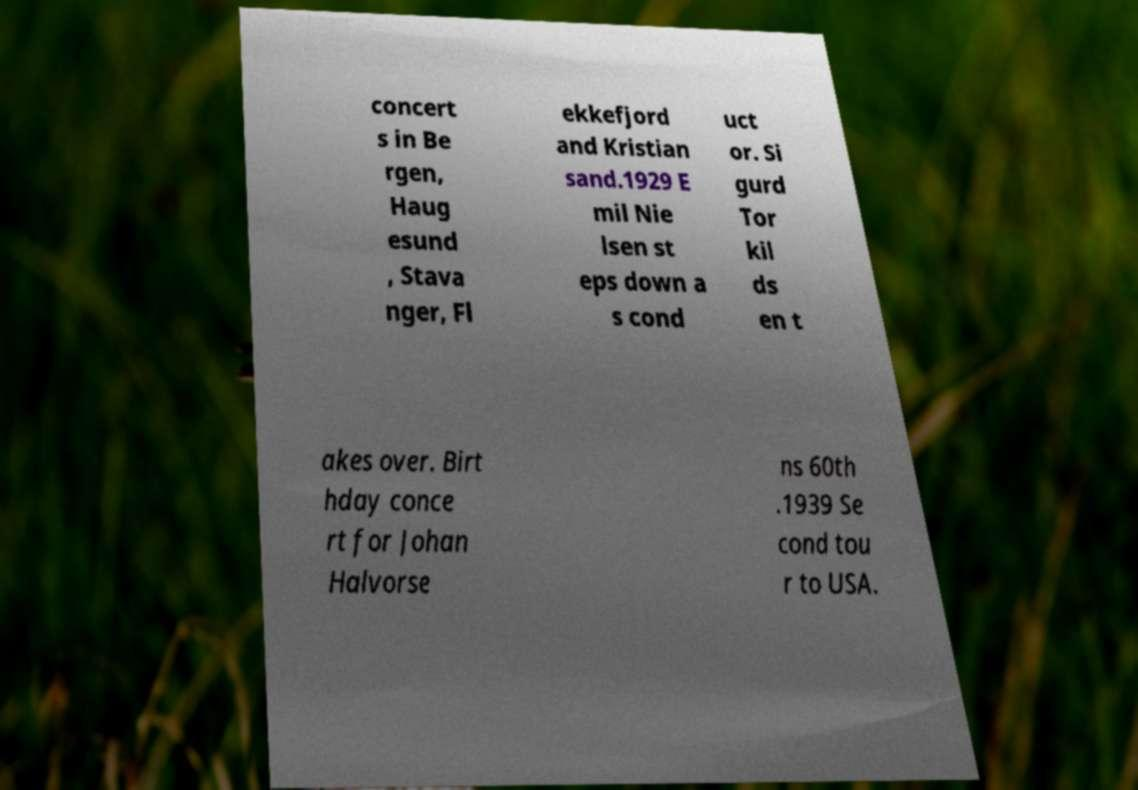Can you read and provide the text displayed in the image?This photo seems to have some interesting text. Can you extract and type it out for me? concert s in Be rgen, Haug esund , Stava nger, Fl ekkefjord and Kristian sand.1929 E mil Nie lsen st eps down a s cond uct or. Si gurd Tor kil ds en t akes over. Birt hday conce rt for Johan Halvorse ns 60th .1939 Se cond tou r to USA. 